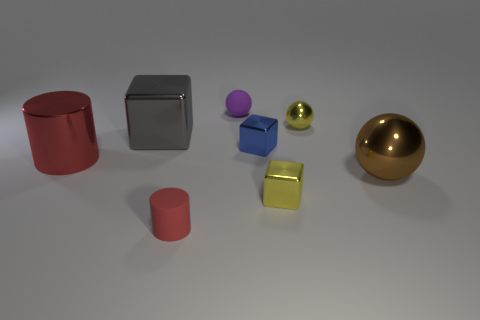Subtract 1 cubes. How many cubes are left? 2 Subtract all large brown metallic spheres. How many spheres are left? 2 Add 1 yellow rubber balls. How many objects exist? 9 Subtract all blocks. How many objects are left? 5 Add 8 blue metallic objects. How many blue metallic objects are left? 9 Add 2 red metal cylinders. How many red metal cylinders exist? 3 Subtract 0 cyan spheres. How many objects are left? 8 Subtract all tiny yellow spheres. Subtract all tiny purple rubber objects. How many objects are left? 6 